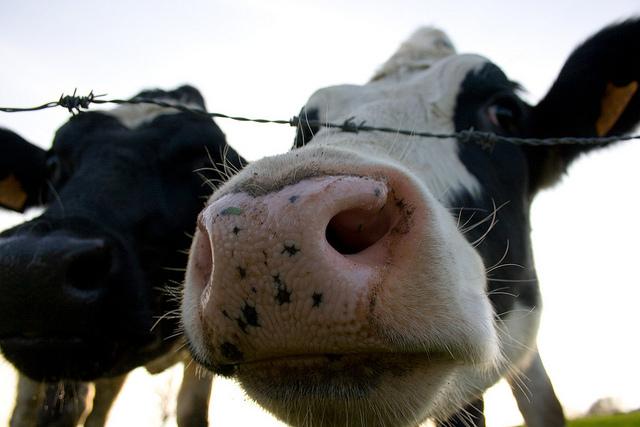How many black spots are on his nose?
Concise answer only. 12. What kind of fence is this?
Write a very short answer. Barbed wire. Do the cows appear agitated?
Concise answer only. No. 